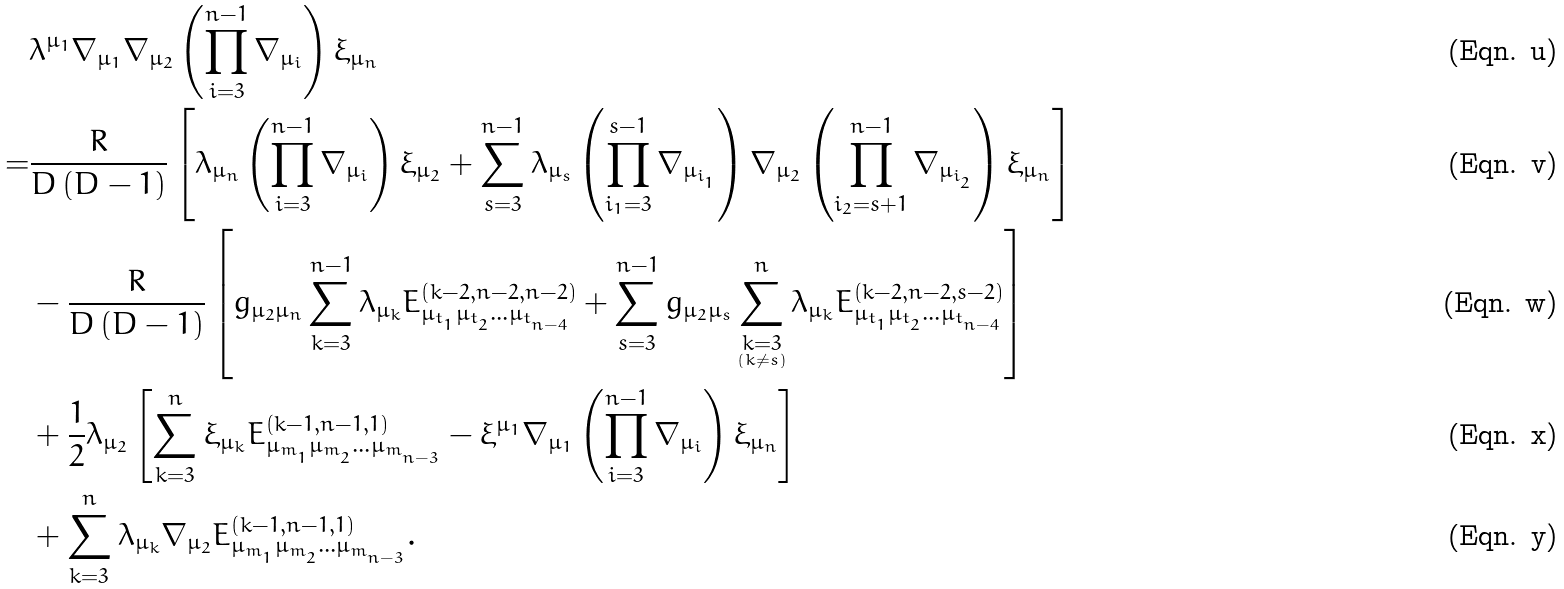<formula> <loc_0><loc_0><loc_500><loc_500>& \lambda ^ { \mu _ { 1 } } \nabla _ { \mu _ { 1 } } \nabla _ { \mu _ { 2 } } \left ( \prod _ { i = 3 } ^ { n - 1 } \nabla _ { \mu _ { i } } \right ) \xi _ { \mu _ { n } } \\ = & \frac { R } { D \left ( D - 1 \right ) } \left [ \lambda _ { \mu _ { n } } \left ( \prod _ { i = 3 } ^ { n - 1 } \nabla _ { \mu _ { i } } \right ) \xi _ { \mu _ { 2 } } + \sum _ { s = 3 } ^ { n - 1 } \lambda _ { \mu _ { s } } \left ( \prod _ { i _ { 1 } = 3 } ^ { s - 1 } \nabla _ { \mu _ { i _ { _ { 1 } } } } \right ) \nabla _ { \mu _ { 2 } } \left ( \prod _ { i _ { 2 } = s + 1 } ^ { n - 1 } \nabla _ { \mu _ { i _ { _ { 2 } } } } \right ) \xi _ { \mu _ { n } } \right ] \\ & - \frac { R } { D \left ( D - 1 \right ) } \left [ g _ { \mu _ { 2 } \mu _ { n } } \sum _ { k = 3 } ^ { n - 1 } \lambda _ { \mu _ { k } } E _ { \mu _ { t _ { _ { 1 } } } \mu _ { t _ { _ { 2 } } } \dots \mu _ { t _ { _ { n - 4 } } } } ^ { \left ( k - 2 , n - 2 , n - 2 \right ) } + \sum _ { s = 3 } ^ { n - 1 } g _ { \mu _ { 2 } \mu _ { s } } \sum _ { \underset { \left ( k \ne s \right ) } { k = 3 } } ^ { n } \lambda _ { \mu _ { k } } E _ { \mu _ { t _ { _ { 1 } } } \mu _ { t _ { _ { 2 } } } \dots \mu _ { t _ { _ { n - 4 } } } } ^ { \left ( k - 2 , n - 2 , s - 2 \right ) } \right ] \\ & + \frac { 1 } { 2 } \lambda _ { \mu _ { 2 } } \left [ \sum _ { k = 3 } ^ { n } \xi _ { \mu _ { k } } E _ { \mu _ { m _ { _ { 1 } } } \mu _ { m _ { _ { 2 } } } \dots \mu _ { m _ { _ { n - 3 } } } } ^ { \left ( k - 1 , n - 1 , 1 \right ) } - \xi ^ { \mu _ { 1 } } \nabla _ { \mu _ { 1 } } \left ( \prod _ { i = 3 } ^ { n - 1 } \nabla _ { \mu _ { i } } \right ) \xi _ { \mu _ { n } } \right ] \\ & + \sum _ { k = 3 } ^ { n } \lambda _ { \mu _ { k } } \nabla _ { \mu _ { 2 } } E _ { \mu _ { m _ { _ { 1 } } } \mu _ { m _ { _ { 2 } } } \dots \mu _ { m _ { _ { n - 3 } } } } ^ { \left ( k - 1 , n - 1 , 1 \right ) } .</formula> 